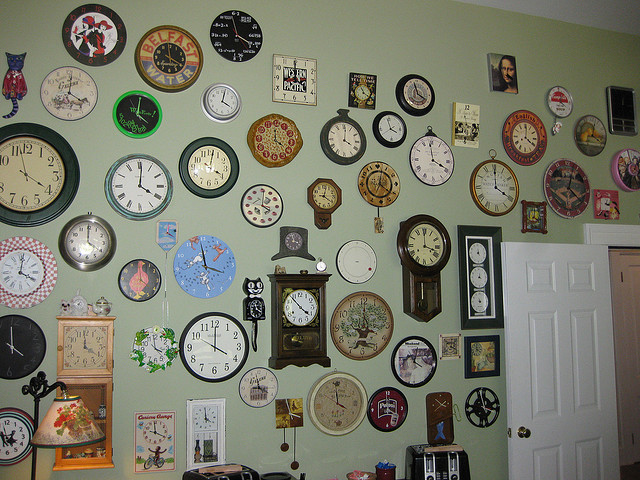What is covering the wall? The wall is decorated with a diverse collection of clocks, ranging from traditional analog pieces to more eclectic designs, showcasing various styles and periods. 